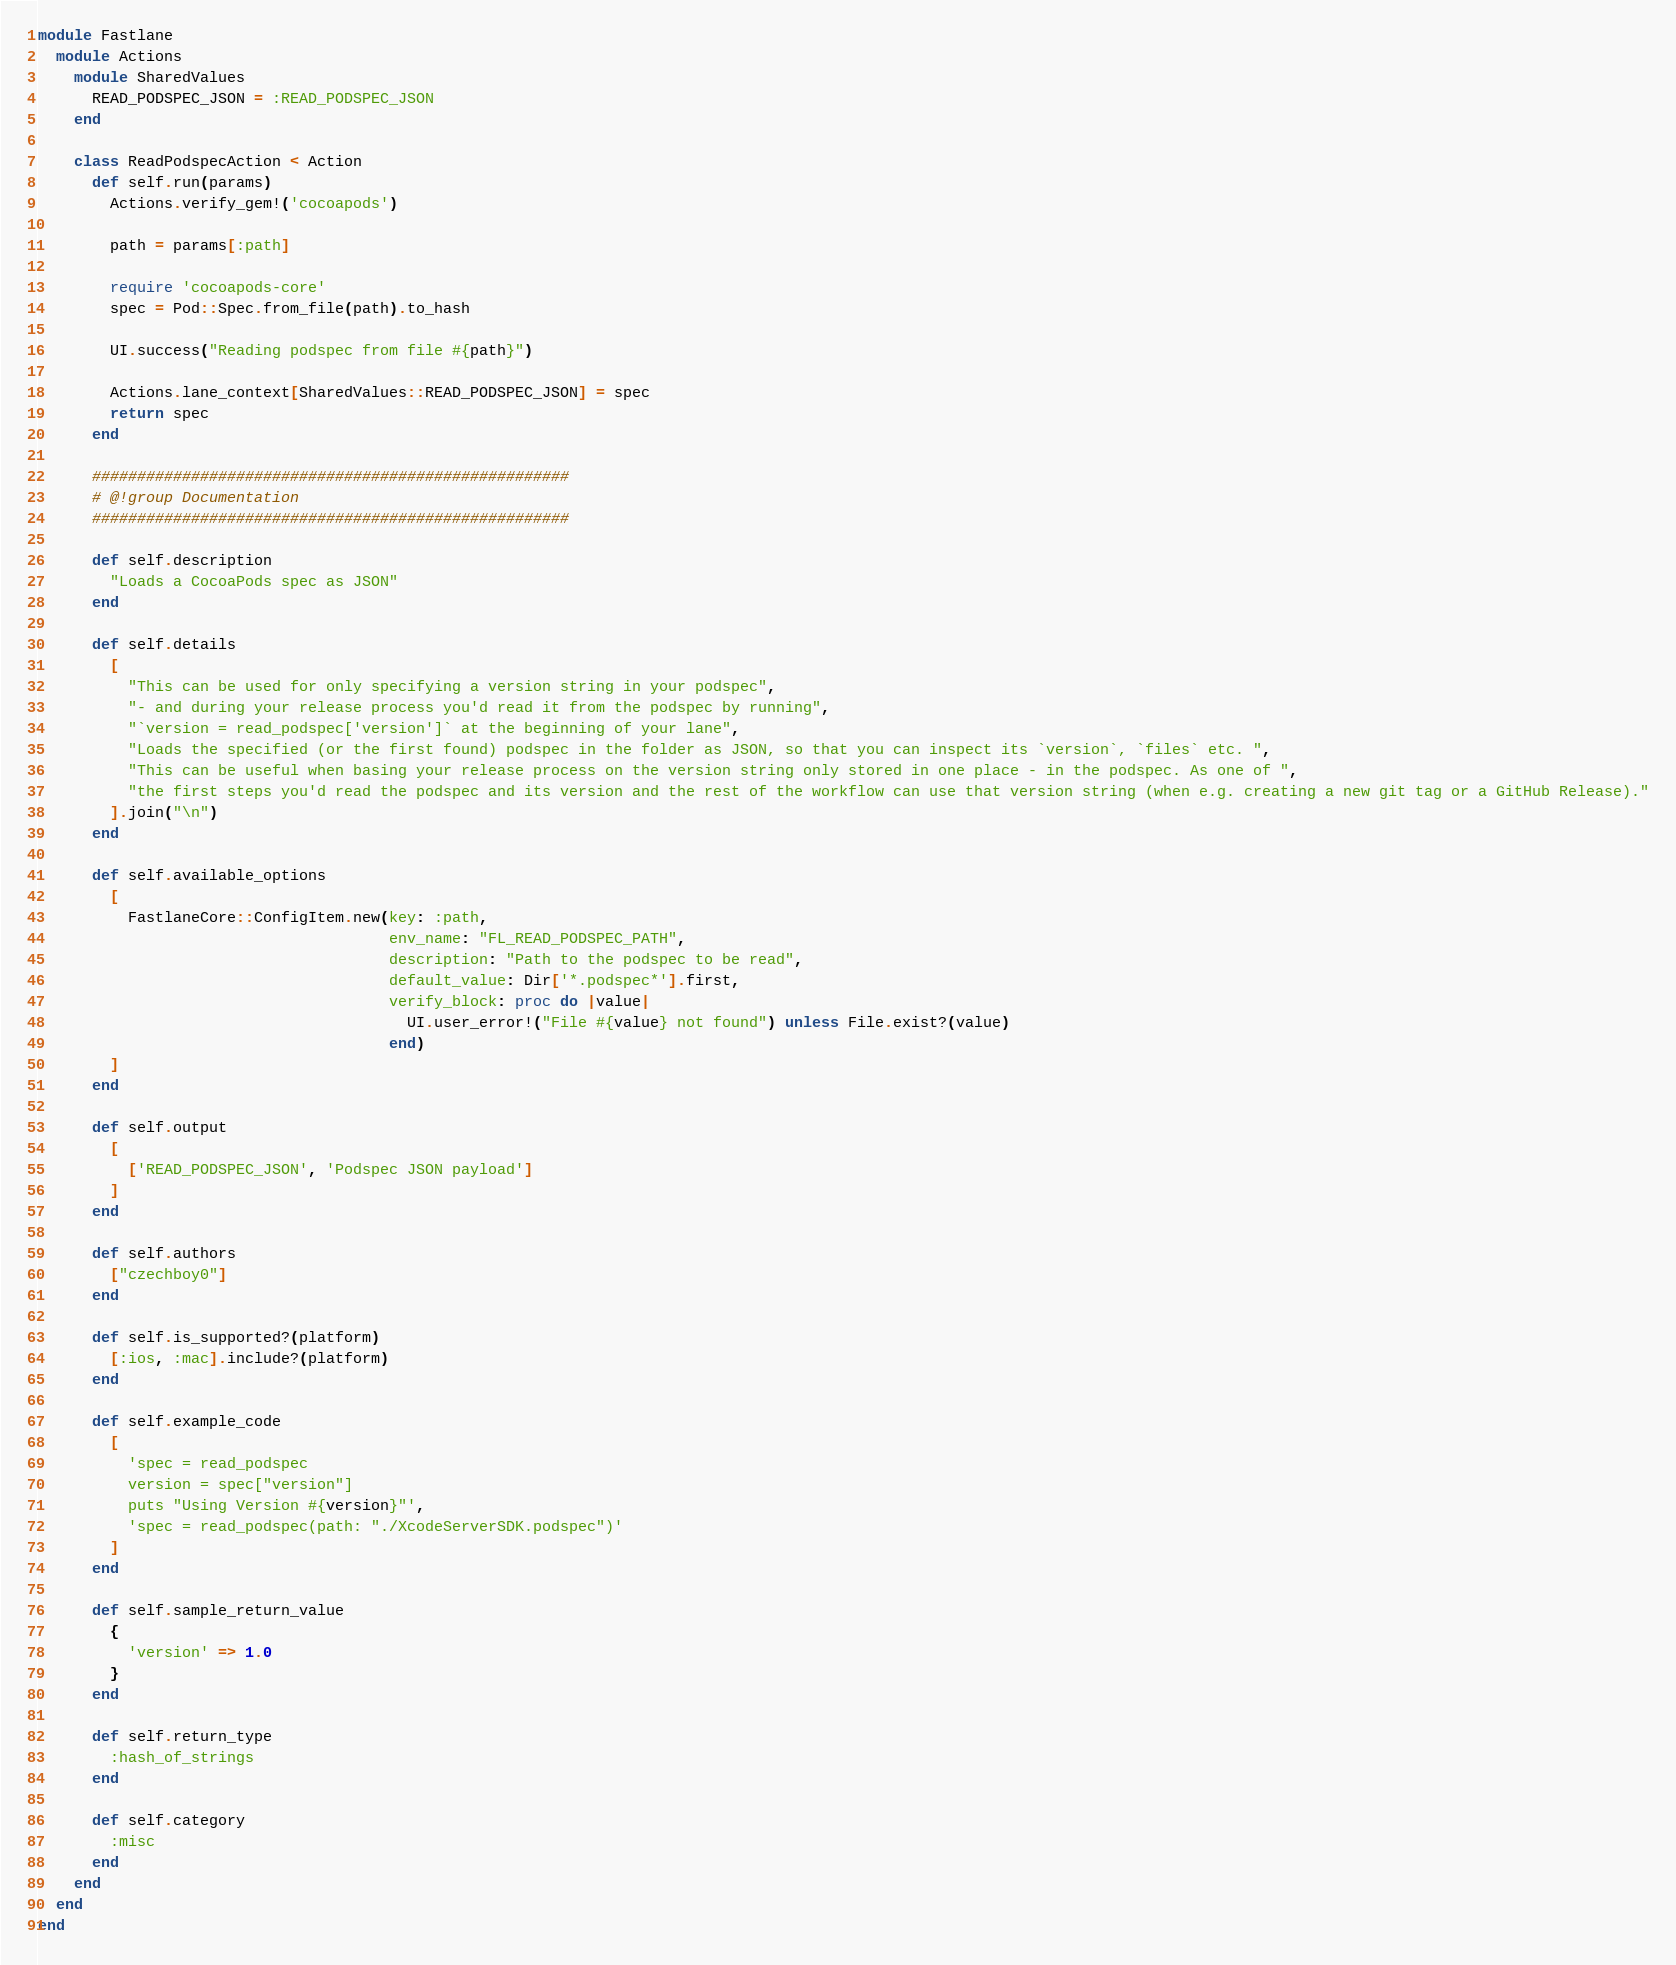<code> <loc_0><loc_0><loc_500><loc_500><_Ruby_>module Fastlane
  module Actions
    module SharedValues
      READ_PODSPEC_JSON = :READ_PODSPEC_JSON
    end

    class ReadPodspecAction < Action
      def self.run(params)
        Actions.verify_gem!('cocoapods')

        path = params[:path]

        require 'cocoapods-core'
        spec = Pod::Spec.from_file(path).to_hash

        UI.success("Reading podspec from file #{path}")

        Actions.lane_context[SharedValues::READ_PODSPEC_JSON] = spec
        return spec
      end

      #####################################################
      # @!group Documentation
      #####################################################

      def self.description
        "Loads a CocoaPods spec as JSON"
      end

      def self.details
        [
          "This can be used for only specifying a version string in your podspec",
          "- and during your release process you'd read it from the podspec by running",
          "`version = read_podspec['version']` at the beginning of your lane",
          "Loads the specified (or the first found) podspec in the folder as JSON, so that you can inspect its `version`, `files` etc. ",
          "This can be useful when basing your release process on the version string only stored in one place - in the podspec. As one of ",
          "the first steps you'd read the podspec and its version and the rest of the workflow can use that version string (when e.g. creating a new git tag or a GitHub Release)."
        ].join("\n")
      end

      def self.available_options
        [
          FastlaneCore::ConfigItem.new(key: :path,
                                       env_name: "FL_READ_PODSPEC_PATH",
                                       description: "Path to the podspec to be read",
                                       default_value: Dir['*.podspec*'].first,
                                       verify_block: proc do |value|
                                         UI.user_error!("File #{value} not found") unless File.exist?(value)
                                       end)
        ]
      end

      def self.output
        [
          ['READ_PODSPEC_JSON', 'Podspec JSON payload']
        ]
      end

      def self.authors
        ["czechboy0"]
      end

      def self.is_supported?(platform)
        [:ios, :mac].include?(platform)
      end

      def self.example_code
        [
          'spec = read_podspec
          version = spec["version"]
          puts "Using Version #{version}"',
          'spec = read_podspec(path: "./XcodeServerSDK.podspec")'
        ]
      end

      def self.sample_return_value
        {
          'version' => 1.0
        }
      end

      def self.return_type
        :hash_of_strings
      end

      def self.category
        :misc
      end
    end
  end
end
</code> 